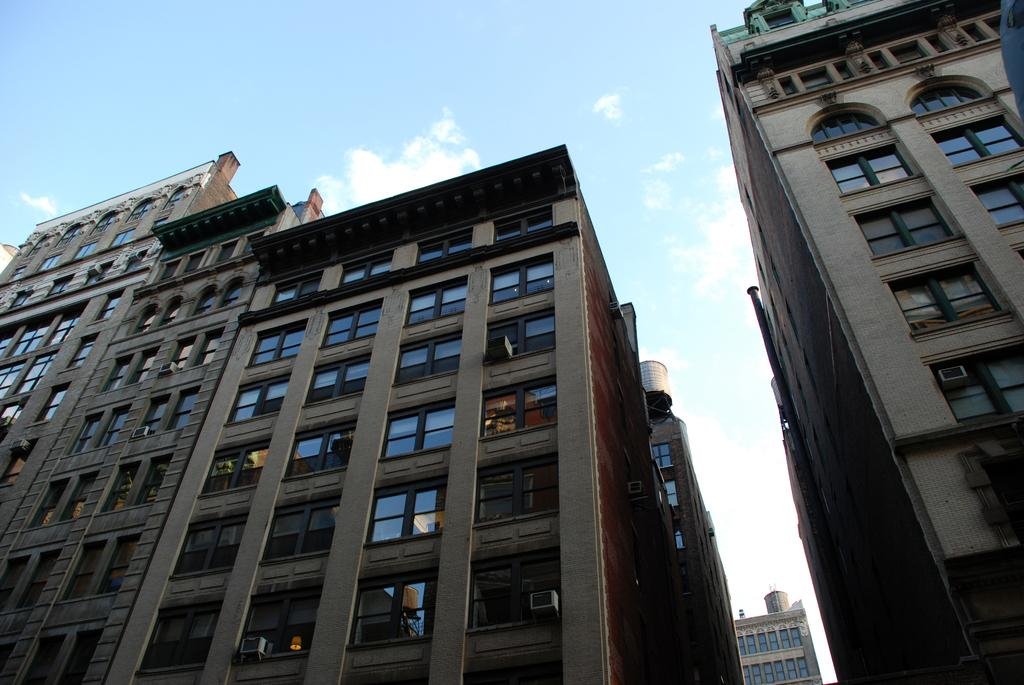What type of structures are visible in the image? There are buildings in the image. What feature can be seen on the buildings? The buildings have windows. What is visible at the top of the image? The sky is visible at the top of the image. What can be observed in the sky? Clouds are present in the sky. What type of butter can be seen on the buildings in the image? There is no butter present on the buildings in the image. 